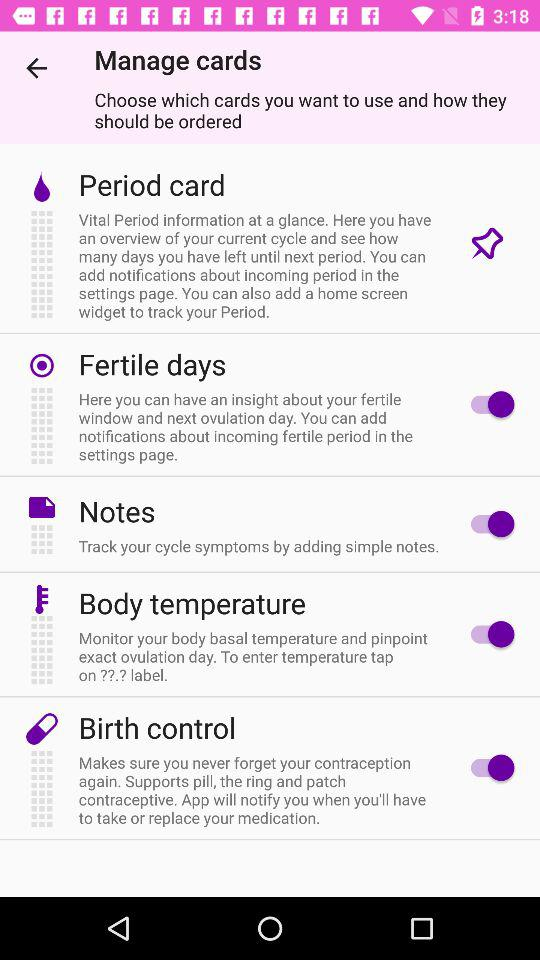What is the status of the "Notes"? The status is "on". 